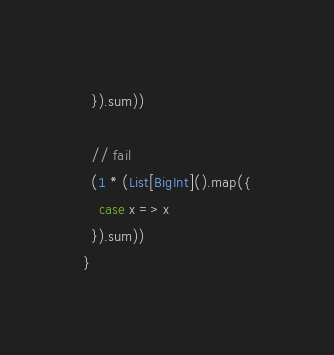Convert code to text. <code><loc_0><loc_0><loc_500><loc_500><_Scala_>  }).sum))

  // fail
  (1 * (List[BigInt]().map({
    case x => x
  }).sum))
}</code> 